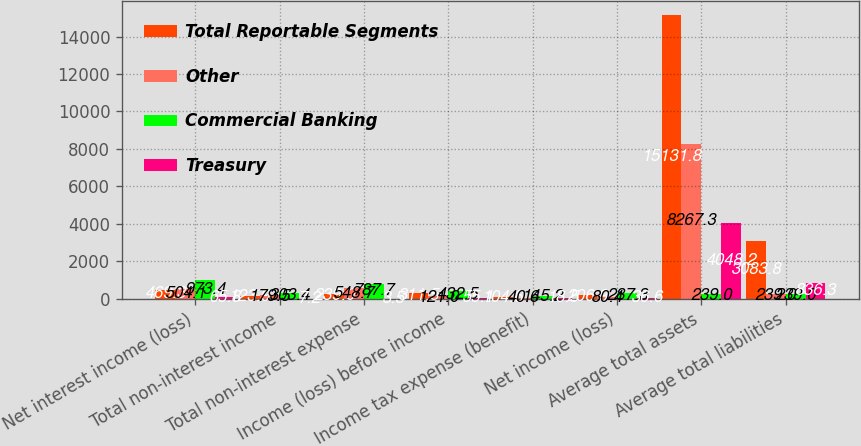Convert chart. <chart><loc_0><loc_0><loc_500><loc_500><stacked_bar_chart><ecel><fcel>Net interest income (loss)<fcel>Total non-interest income<fcel>Total non-interest expense<fcel>Income (loss) before income<fcel>Income tax expense (benefit)<fcel>Net income (loss)<fcel>Average total assets<fcel>Average total liabilities<nl><fcel>Total Reportable Segments<fcel>469.3<fcel>123.9<fcel>239<fcel>311.5<fcel>104.6<fcel>206.9<fcel>15131.8<fcel>3083.8<nl><fcel>Other<fcel>504.1<fcel>179.5<fcel>548.7<fcel>121<fcel>40.6<fcel>80.4<fcel>8267.3<fcel>239<nl><fcel>Commercial Banking<fcel>973.4<fcel>303.4<fcel>787.7<fcel>432.5<fcel>145.2<fcel>287.3<fcel>239<fcel>239<nl><fcel>Treasury<fcel>65.8<fcel>7.2<fcel>3.5<fcel>55.1<fcel>18.5<fcel>36.6<fcel>4048.2<fcel>836.3<nl></chart> 